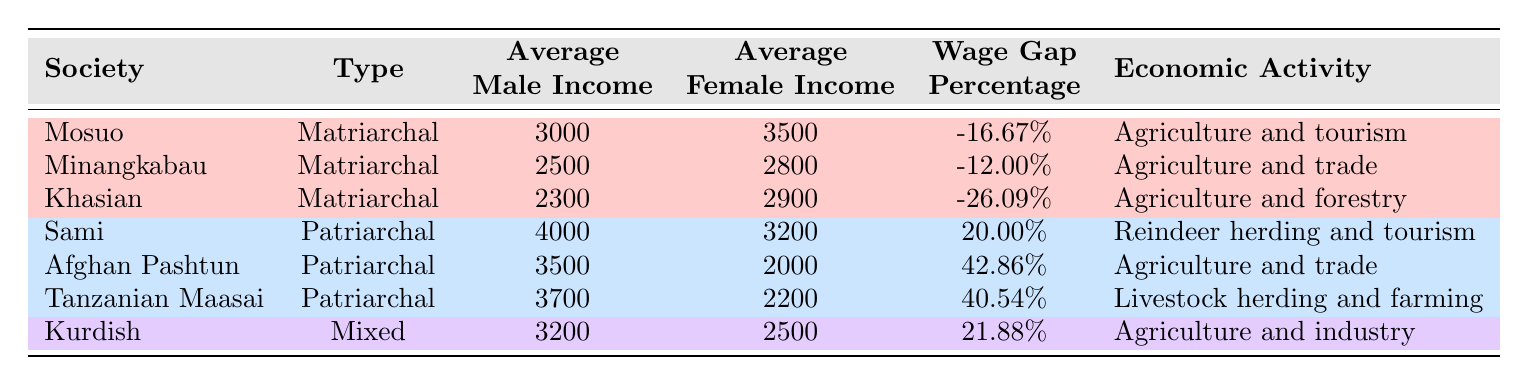What is the wage gap percentage in the Mosuo society? The table states that the wage gap percentage for the Mosuo society is -16.67%, which indicates that women earn more than men.
Answer: -16.67% Which society has the highest average male income? According to the table, the Sami society has the highest average male income at 4000.
Answer: 4000 What is the average female income in the Khasian society? Referring to the table, the average female income in the Khasian society is 2900.
Answer: 2900 Is the average male income in the Afghan Pashtun society greater than that in the Tanzanian Maasai society? The average male income for the Afghan Pashtun is 3500, while for the Tanzanian Maasai it is 3700. Therefore, the Afghan Pashtun's average male income is not greater than that of the Tanzanian Maasai.
Answer: No What is the average wage gap percentage for matriarchal societies? We calculate the average wage gap percentage for the three matriarchal societies: (-16.67 - 12.00 - 26.09) / 3 = -18.92%. Thus, the average wage gap percentage is approximately -18.92%.
Answer: -18.92% Which society has the least favorable wage gap for women? The Afghan Pashtun society, with a wage gap percentage of 42.86%, has the least favorable wage gap for women, indicating women's earnings are significantly lower than men's.
Answer: Afghan Pashtun How does the average female income compare between matriarchal and patriarchal societies? The average female income for matriarchal societies is (3500 + 2800 + 2900) / 3 = 3066.67, while for patriarchal societies, it is (3200 + 2000 + 2200) / 3 = 2466.67. Therefore, women's average incomes in matriarchal societies are higher compared to patriarchal societies.
Answer: Higher in matriarchal societies What economic activity is associated with the Khasian society? The Khasian society's economic activity is listed as agriculture and forestry in the table.
Answer: Agriculture and forestry How many societies have a negative wage gap percentage? The table lists three societies with negative wage gap percentages: Mosuo, Minangkabau, and Khasian. Therefore, there are three societies in total.
Answer: Three 